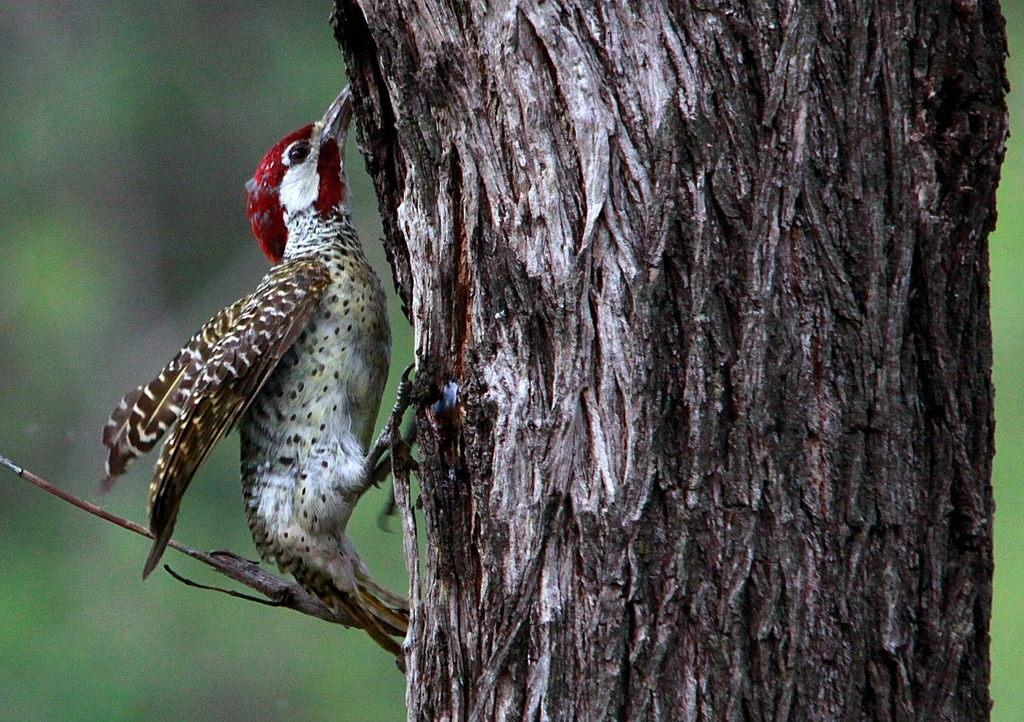What type of animal is in the image? There is a small bird in the image. Can you describe the bird's coloring? The bird has white and brown colors. What is the bird hanging on in the image? The bird is hanging on a wooden trunk. How would you describe the background of the image? The background of the image is blurred. What type of tax does the bird pay while hanging on the wooden trunk in the image? There is no mention of taxes in the image, and the bird is not shown engaging in any activity that would require paying a tax. 